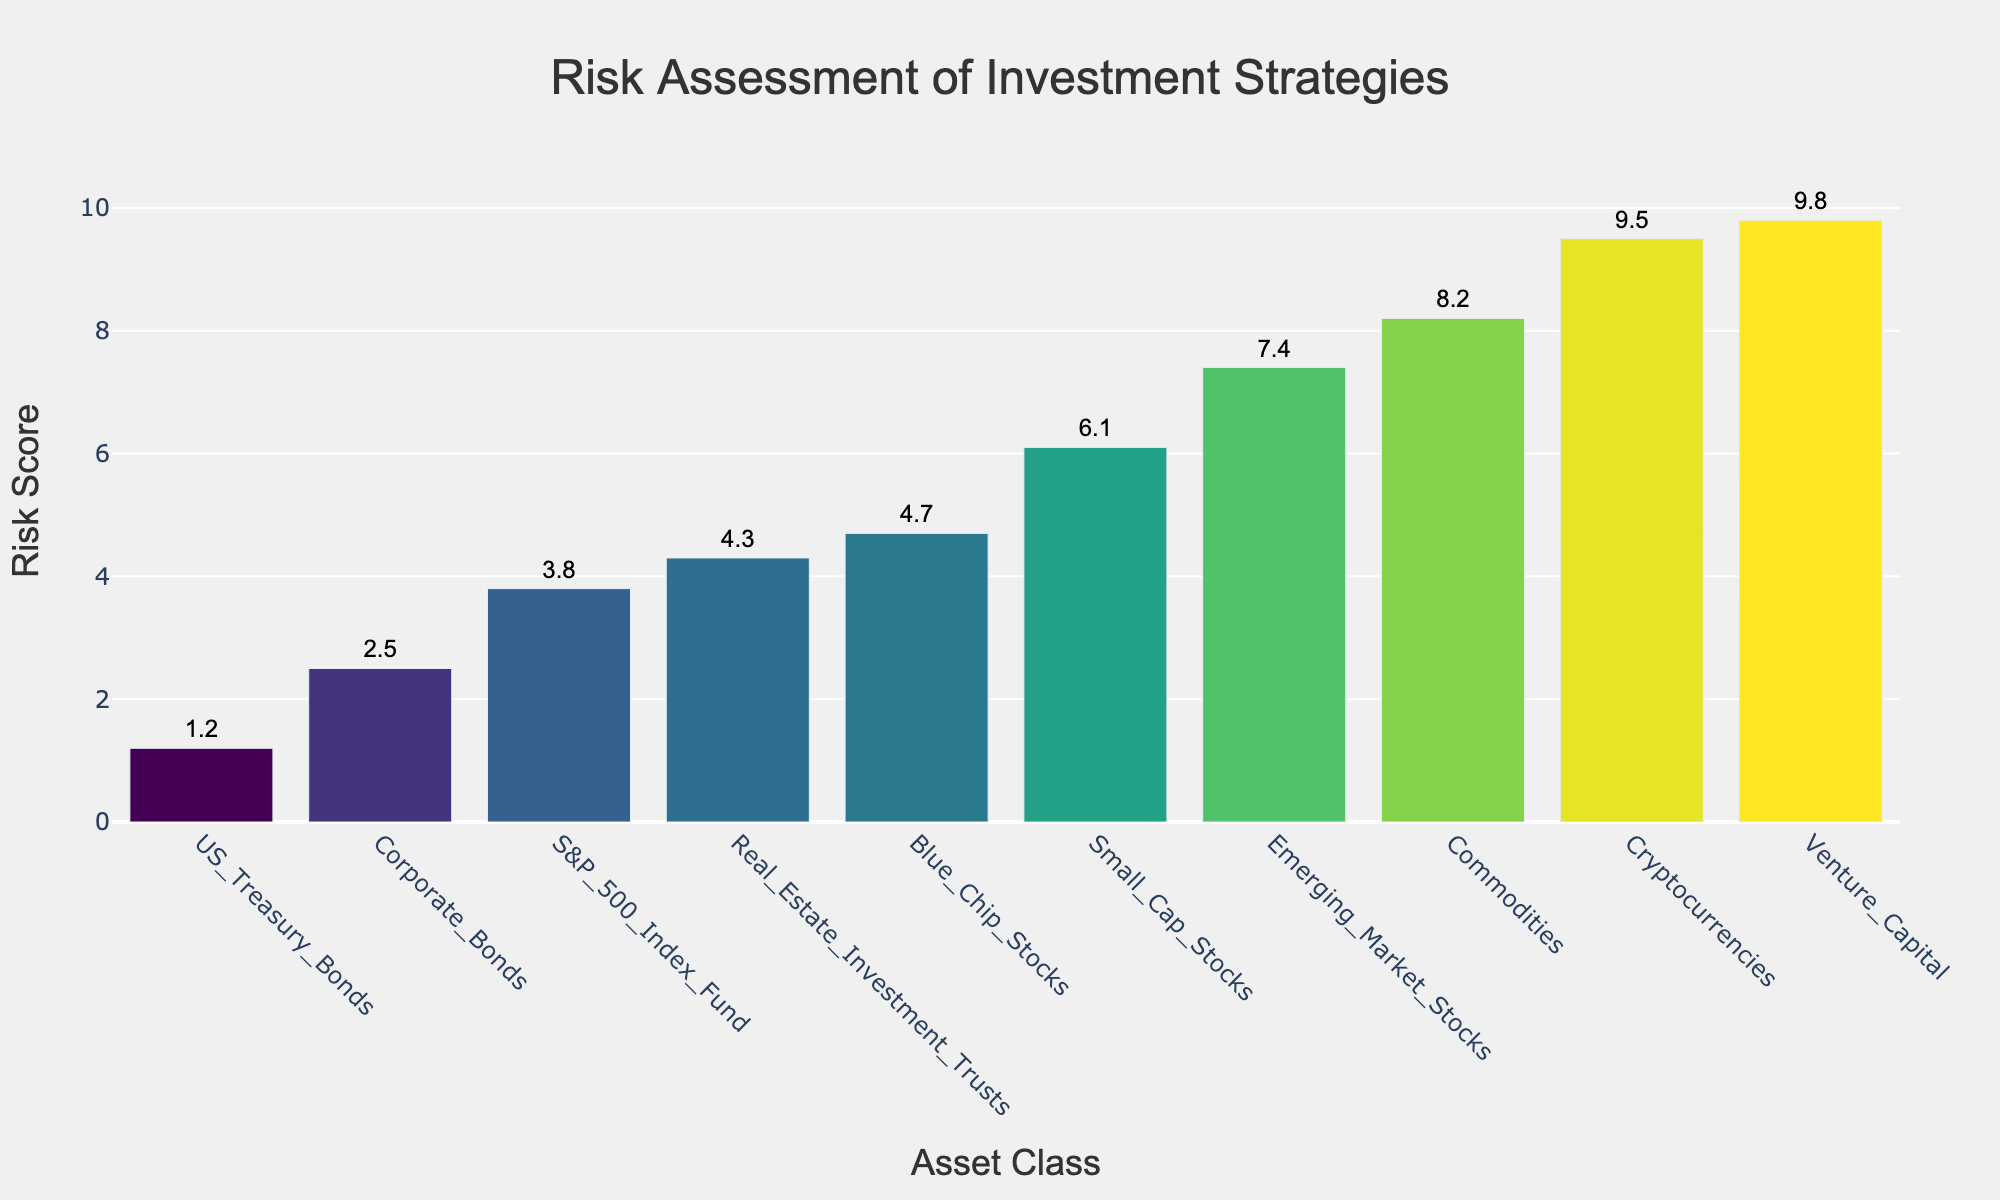How many asset classes are displayed in the plot? The figure shows bars corresponding to each asset class. By counting the bars, we find that there are 10 asset classes in total.
Answer: 10 Which asset class has the highest risk score? Looking at the figure, the bar with the highest value represents the asset class with the highest risk score. The tallest bar corresponds to 'Venture Capital' with a risk score of 9.8.
Answer: Venture Capital What is the risk score for Blue Chip Stocks? The bar corresponding to Blue Chip Stocks is labeled with its risk score. Reading from the label, the risk score for Blue Chip Stocks is 4.7.
Answer: 4.7 Which asset class has the lowest risk score, and what is the score? The figure shows the bar with the lowest height representing the asset class with the lowest risk score. The shortest bar corresponds to 'US Treasury Bonds' with a risk score of 1.2.
Answer: US Treasury Bonds, 1.2 What is the difference in risk score between Small Cap Stocks and Cryptocurrencies? First, identify the bars for Small Cap Stocks and Cryptocurrencies from the figure. The risk score for Small Cap Stocks is 6.1, and for Cryptocurrencies, it is 9.5. Subtracting these values gives us 9.5 - 6.1 = 3.4.
Answer: 3.4 What is the average risk score across all asset classes? The figure displays risk scores for all 10 asset classes. Summing these scores (1.2 + 2.5 + 3.8 + 4.3 + 4.7 + 6.1 + 7.4 + 8.2 + 9.5 + 9.8) gives a total of 57.5. Dividing this total by 10 gives an average risk score of 5.75.
Answer: 5.75 Which asset class has a higher risk score, Corporate Bonds or Real Estate Investment Trusts? Identify the bars for Corporate Bonds and Real Estate Investment Trusts from the figure. Corporate Bonds have a risk score of 2.5 and Real Estate Investment Trusts have a risk score of 4.3. Since 4.3 is greater than 2.5, Real Estate Investment Trusts have a higher risk score.
Answer: Real Estate Investment Trusts What is the median risk score of the asset classes? To find the median risk score, first list all the risk scores in ascending order: 1.2, 2.5, 3.8, 4.3, 4.7, 6.1, 7.4, 8.2, 9.5, 9.8. With 10 data points, the median is the average of the 5th and 6th values: (4.7 + 6.1) / 2 = 5.4.
Answer: 5.4 Which two asset classes have the closest risk scores? Compare the differences between consecutive risk scores shown on the bars. Blue Chip Stocks and Real Estate Investment Trusts have the closest scores, with a difference of 4.7 - 4.3 = 0.4.
Answer: Blue Chip Stocks and Real Estate Investment Trusts What is the title of the plot? The title of the plot is displayed clearly at the top of the figure and reads 'Risk Assessment of Investment Strategies'.
Answer: Risk Assessment of Investment Strategies 